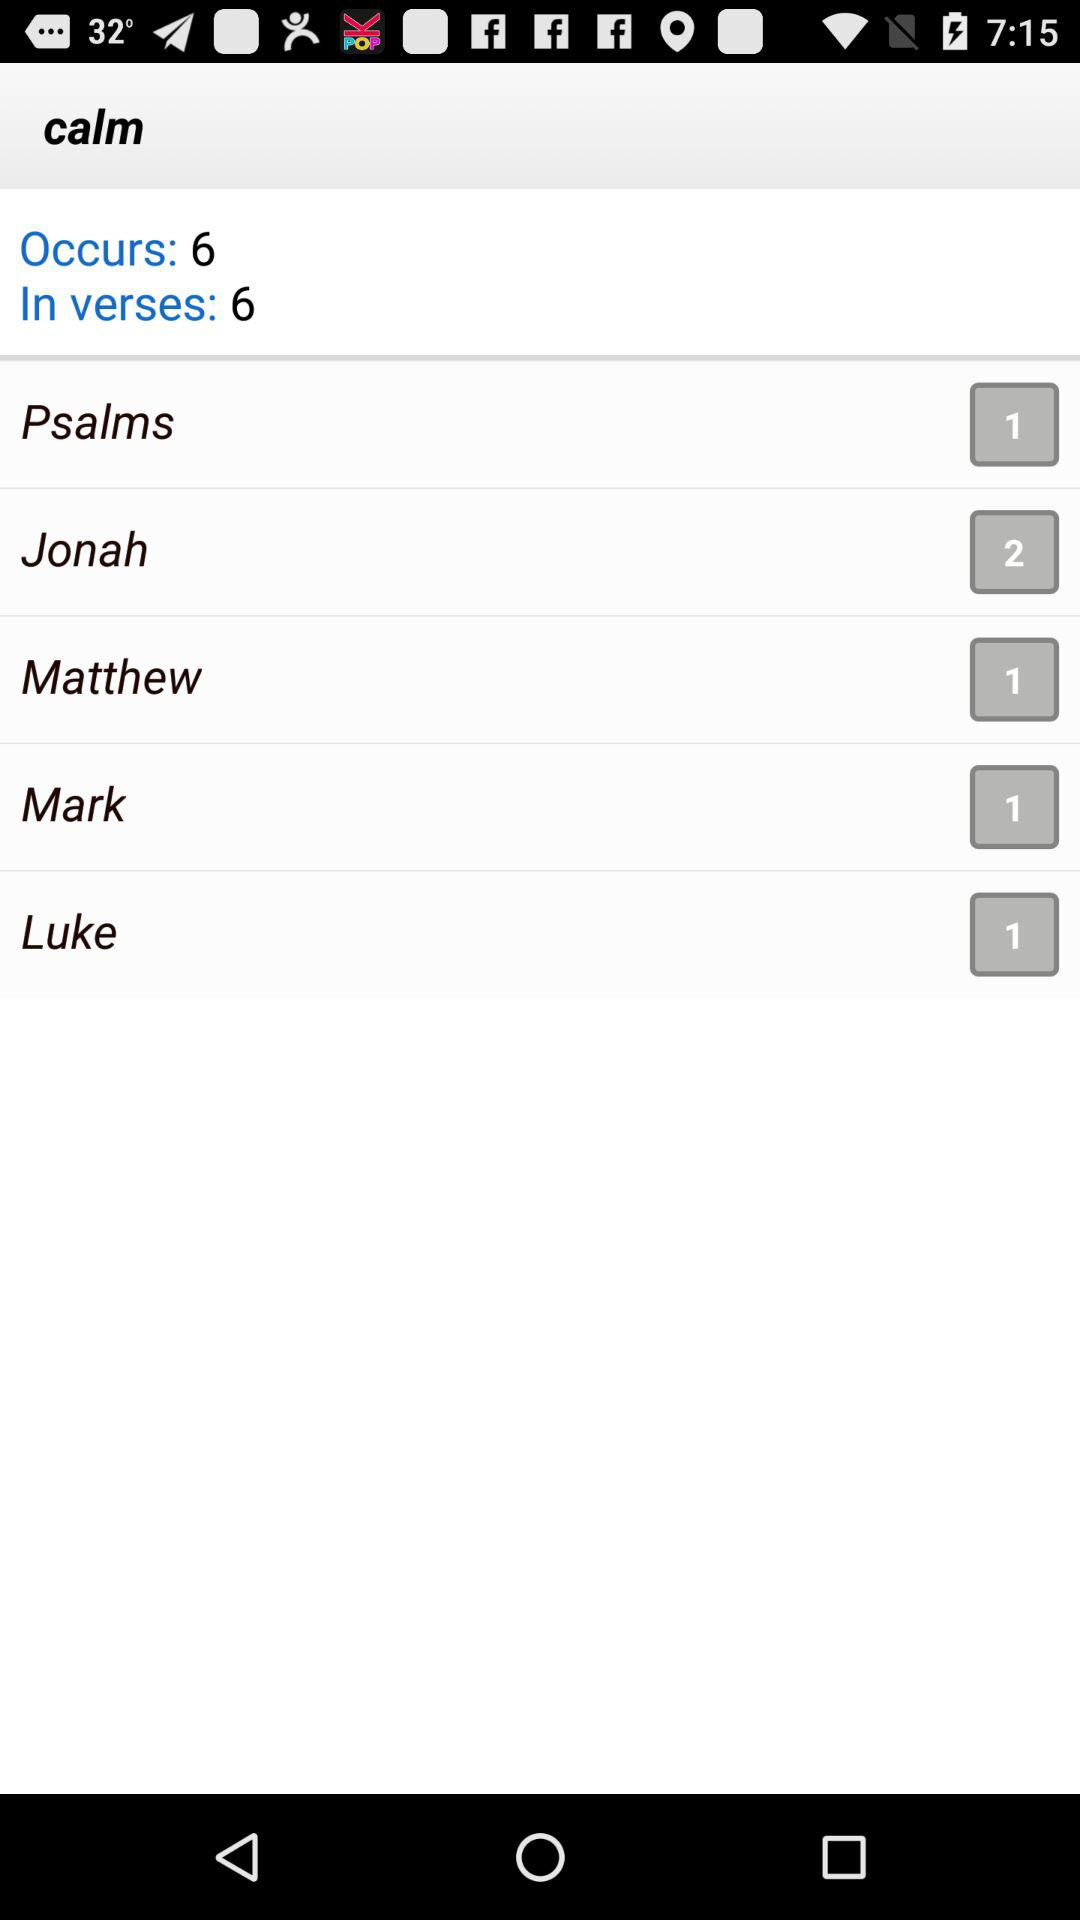What is the number of psalms? The number of psalms is 1. 